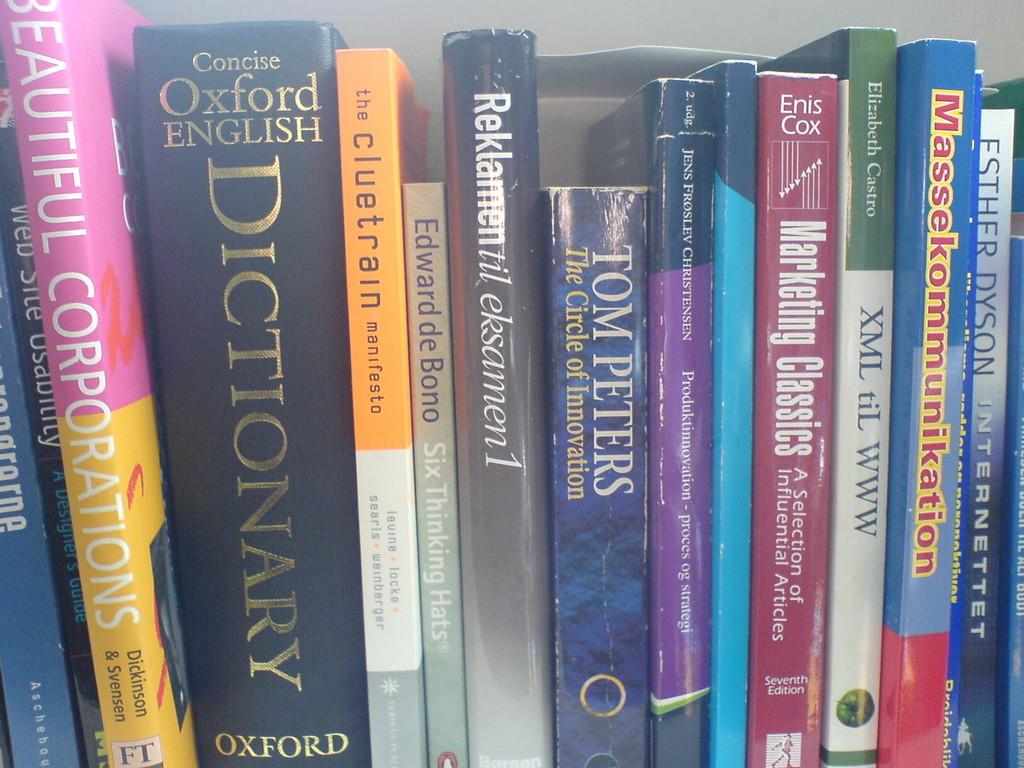Who wrote the circle of innovation?
Provide a succinct answer. Tom peters. 